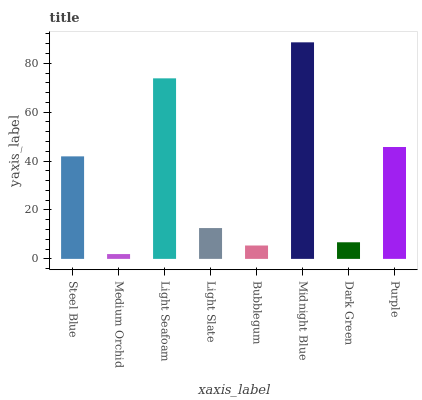Is Medium Orchid the minimum?
Answer yes or no. Yes. Is Midnight Blue the maximum?
Answer yes or no. Yes. Is Light Seafoam the minimum?
Answer yes or no. No. Is Light Seafoam the maximum?
Answer yes or no. No. Is Light Seafoam greater than Medium Orchid?
Answer yes or no. Yes. Is Medium Orchid less than Light Seafoam?
Answer yes or no. Yes. Is Medium Orchid greater than Light Seafoam?
Answer yes or no. No. Is Light Seafoam less than Medium Orchid?
Answer yes or no. No. Is Steel Blue the high median?
Answer yes or no. Yes. Is Light Slate the low median?
Answer yes or no. Yes. Is Purple the high median?
Answer yes or no. No. Is Light Seafoam the low median?
Answer yes or no. No. 